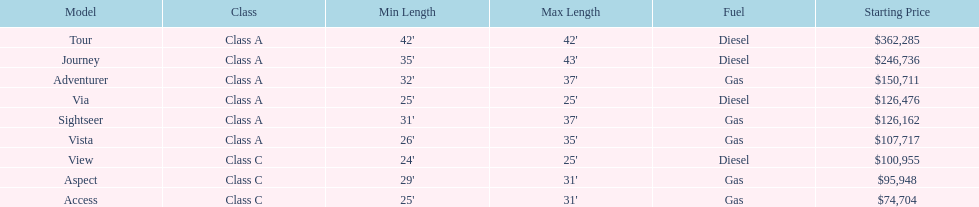Does the tour take diesel or gas? Diesel. 